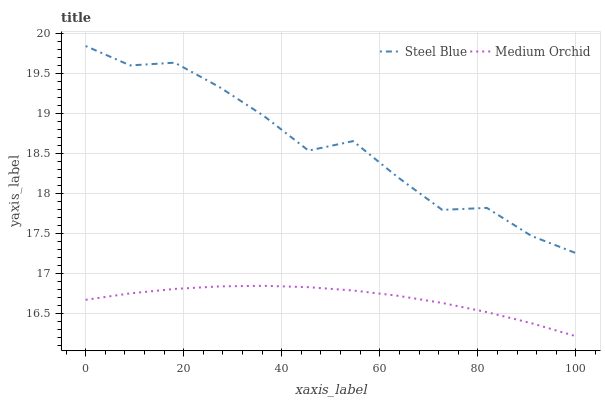Does Medium Orchid have the minimum area under the curve?
Answer yes or no. Yes. Does Steel Blue have the maximum area under the curve?
Answer yes or no. Yes. Does Steel Blue have the minimum area under the curve?
Answer yes or no. No. Is Medium Orchid the smoothest?
Answer yes or no. Yes. Is Steel Blue the roughest?
Answer yes or no. Yes. Is Steel Blue the smoothest?
Answer yes or no. No. Does Medium Orchid have the lowest value?
Answer yes or no. Yes. Does Steel Blue have the lowest value?
Answer yes or no. No. Does Steel Blue have the highest value?
Answer yes or no. Yes. Is Medium Orchid less than Steel Blue?
Answer yes or no. Yes. Is Steel Blue greater than Medium Orchid?
Answer yes or no. Yes. Does Medium Orchid intersect Steel Blue?
Answer yes or no. No. 